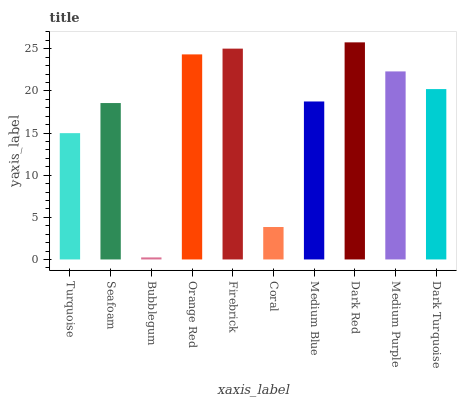Is Seafoam the minimum?
Answer yes or no. No. Is Seafoam the maximum?
Answer yes or no. No. Is Seafoam greater than Turquoise?
Answer yes or no. Yes. Is Turquoise less than Seafoam?
Answer yes or no. Yes. Is Turquoise greater than Seafoam?
Answer yes or no. No. Is Seafoam less than Turquoise?
Answer yes or no. No. Is Dark Turquoise the high median?
Answer yes or no. Yes. Is Medium Blue the low median?
Answer yes or no. Yes. Is Bubblegum the high median?
Answer yes or no. No. Is Bubblegum the low median?
Answer yes or no. No. 